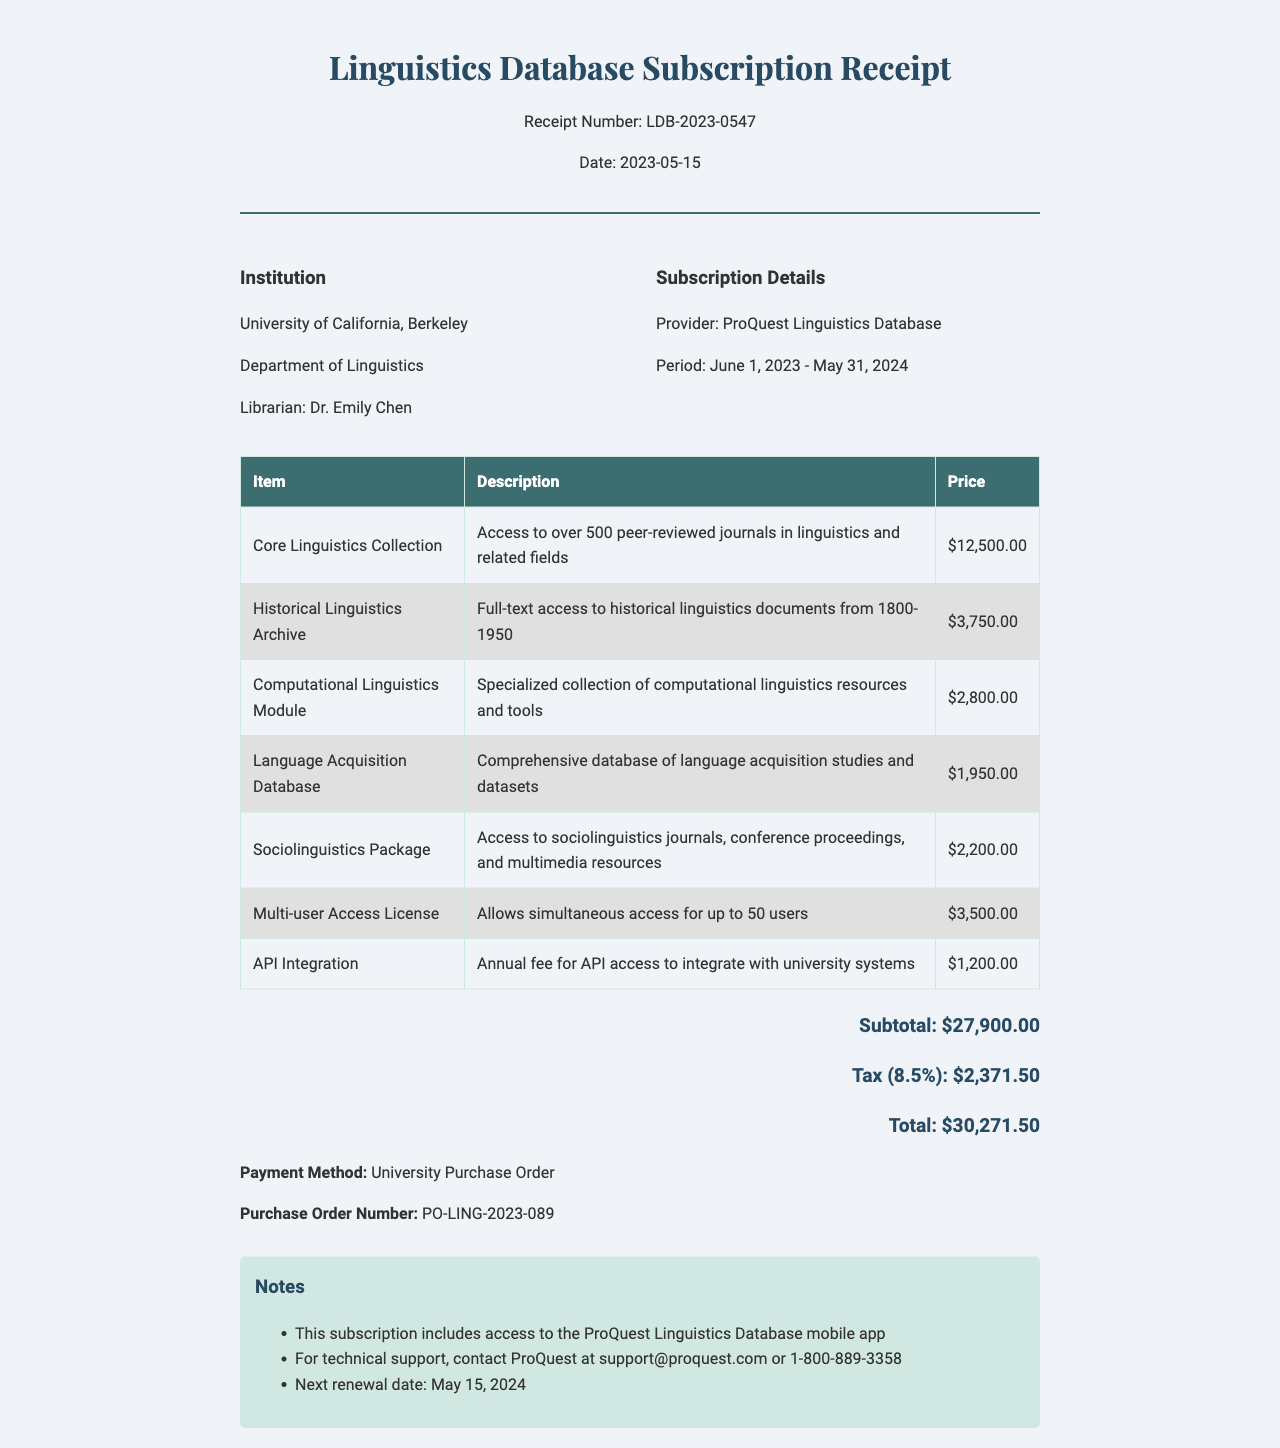what is the receipt number? The receipt number is a unique identifier for the transaction, which is LDB-2023-0547.
Answer: LDB-2023-0547 what is the total amount due? The total amount due is the final charge on the receipt, which includes subtotals, taxes, and additional fees.
Answer: $30,271.50 who is the librarian associated with this receipt? The librarian is the individual responsible for the transaction recorded on this receipt, which is Dr. Emily Chen.
Answer: Dr. Emily Chen what is the subscription period for the database? The subscription period indicates the timeframe for access to the database, which is from June 1, 2023 to May 31, 2024.
Answer: June 1, 2023 - May 31, 2024 how much is the fee for the Core Linguistics Collection? This fee represents the cost for a specific item in the subscription, which is $12,500.00.
Answer: $12,500.00 what additional fee allows simultaneous access for multiple users? This fee permits multiple users to access the database at the same time, which is the Multi-user Access License.
Answer: Multi-user Access License what is the tax rate applied to this receipt? The tax rate is the percentage used to calculate the tax amount on the total, which is 8.5%.
Answer: 8.5% what is the purchase order number associated with this transaction? The purchase order number serves as a reference for the financial transaction, which is PO-LING-2023-089.
Answer: PO-LING-2023-089 when is the next renewal date for the subscription? The next renewal date indicates when the subscription will need to be renewed, which is May 15, 2024.
Answer: May 15, 2024 